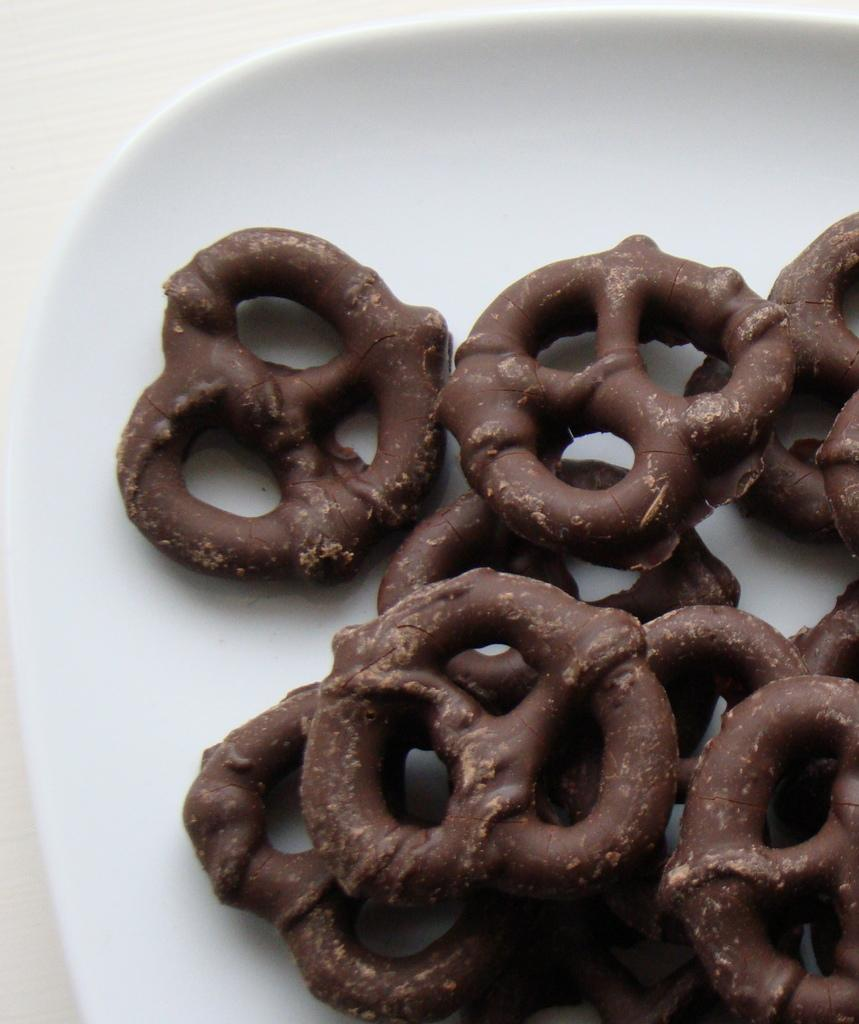What is the color of the plate in the image? The plate in the image is white. What is on the plate? The plate contains snacks. What is the color of the snacks? The snacks are in brown color. How does the bridge connect the two sides of the plate in the image? There is no bridge present in the image; it features a white plate with brown snacks. 